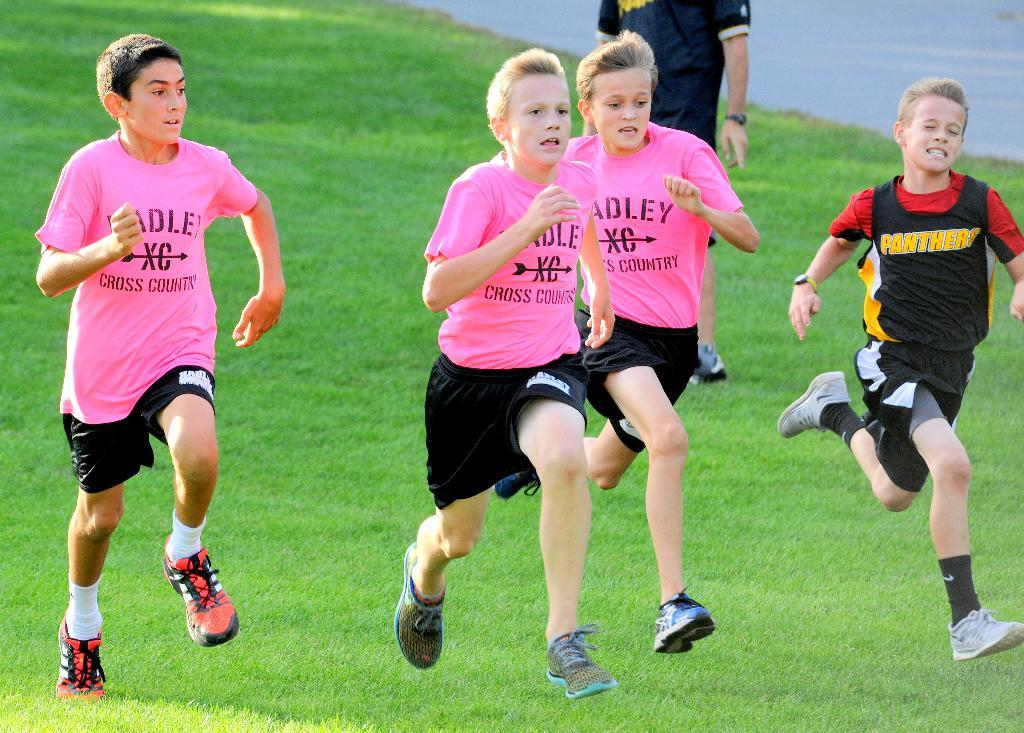What are the people in the image doing? There are four persons running on the grassy land in the image. Is there anyone else in the image besides the runners? Yes, there is a person standing behind the running persons. What type of terrain is visible in the image? The grassy land is visible in the image. What else can be seen in the image? There is a road visible in the top right corner of the image. What type of legal advice is the lawyer providing to the runners in the image? There is no lawyer present in the image, so no legal advice can be provided. What type of butter is being used to grease the form in the image? There is no butter or form present in the image. 